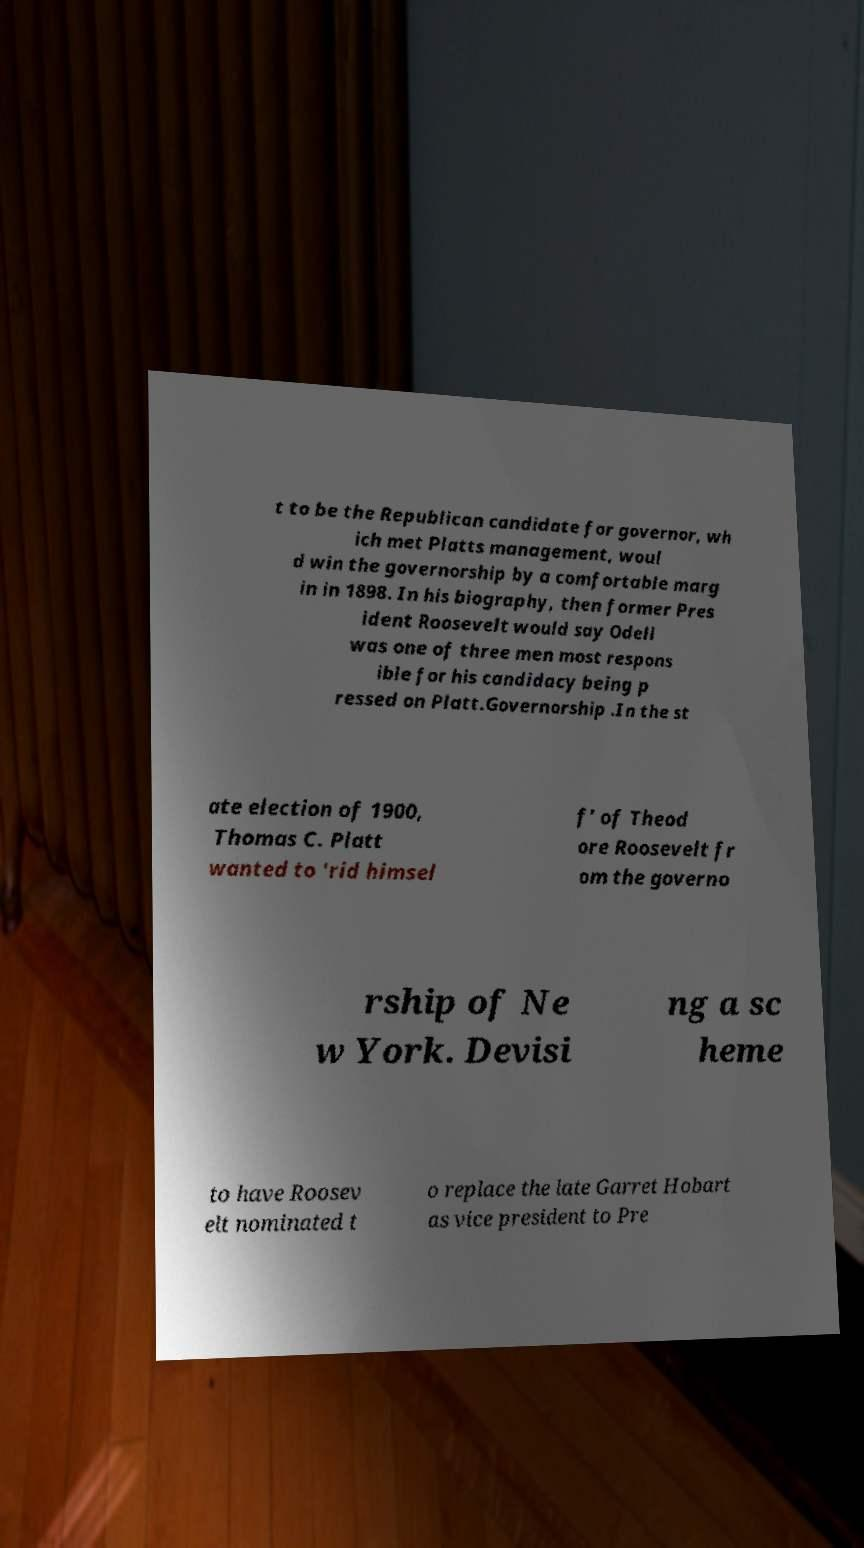What messages or text are displayed in this image? I need them in a readable, typed format. t to be the Republican candidate for governor, wh ich met Platts management, woul d win the governorship by a comfortable marg in in 1898. In his biography, then former Pres ident Roosevelt would say Odell was one of three men most respons ible for his candidacy being p ressed on Platt.Governorship .In the st ate election of 1900, Thomas C. Platt wanted to 'rid himsel f' of Theod ore Roosevelt fr om the governo rship of Ne w York. Devisi ng a sc heme to have Roosev elt nominated t o replace the late Garret Hobart as vice president to Pre 